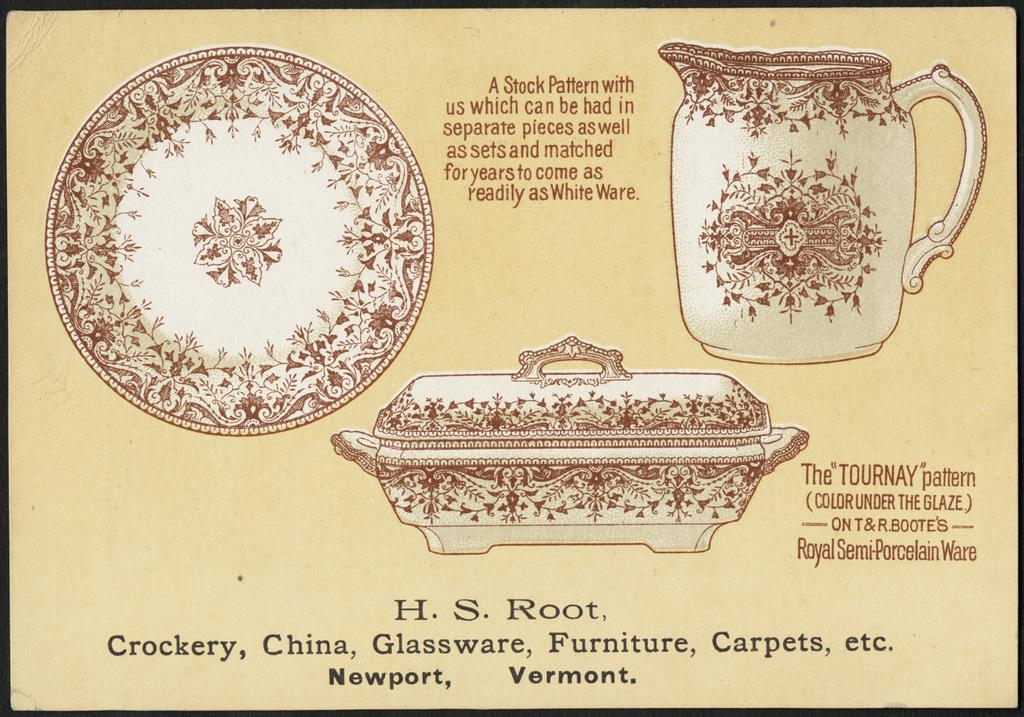What is the main subject of the image? The main subject of the image is a poster. What type of objects are depicted on the poster? The poster contains images of a mug, plate, and bowl with designs. Is there any text on the poster? Yes, there is text on the poster. What type of flesh can be seen on the farmer in the image? There is no farmer or flesh present in the image; it only features a poster with images of a mug, plate, and bowl with designs and text. 